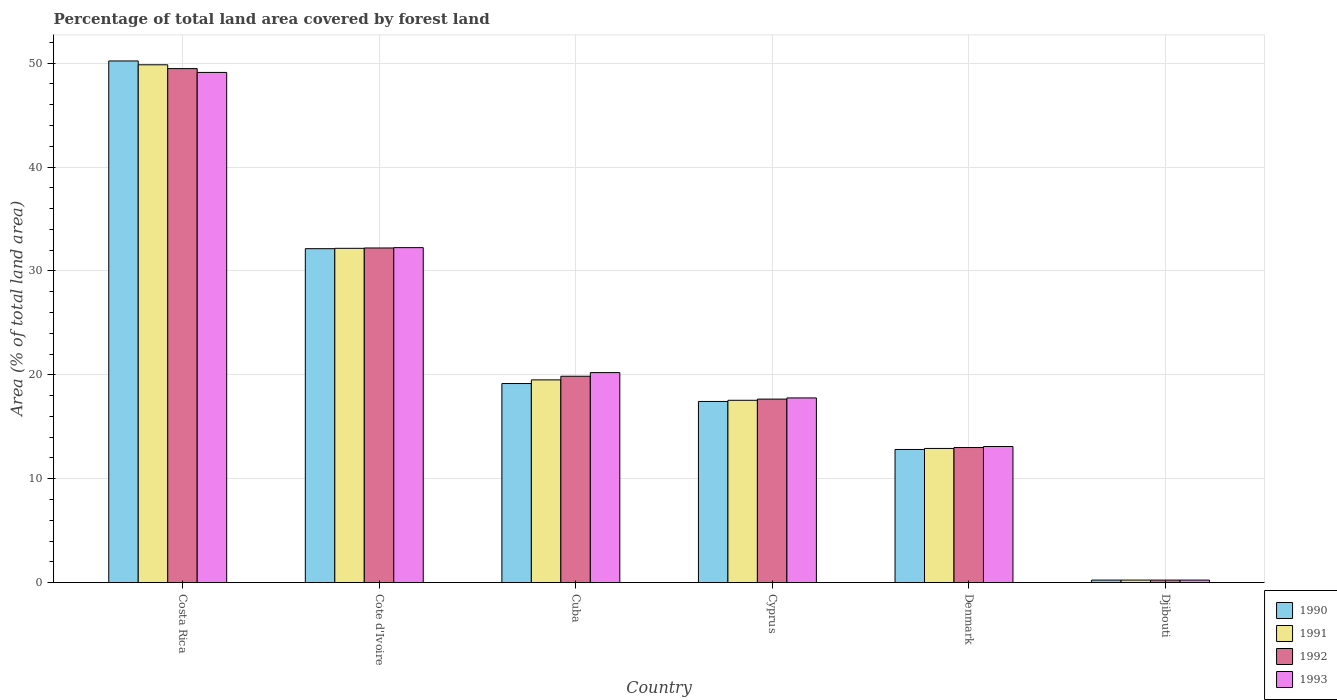How many different coloured bars are there?
Provide a short and direct response. 4. How many groups of bars are there?
Offer a very short reply. 6. Are the number of bars on each tick of the X-axis equal?
Offer a very short reply. Yes. How many bars are there on the 3rd tick from the left?
Keep it short and to the point. 4. What is the percentage of forest land in 1992 in Djibouti?
Provide a short and direct response. 0.24. Across all countries, what is the maximum percentage of forest land in 1993?
Provide a succinct answer. 49.11. Across all countries, what is the minimum percentage of forest land in 1990?
Provide a succinct answer. 0.24. In which country was the percentage of forest land in 1992 minimum?
Provide a succinct answer. Djibouti. What is the total percentage of forest land in 1992 in the graph?
Ensure brevity in your answer.  132.46. What is the difference between the percentage of forest land in 1990 in Cyprus and that in Denmark?
Your response must be concise. 4.62. What is the difference between the percentage of forest land in 1993 in Denmark and the percentage of forest land in 1990 in Cuba?
Offer a very short reply. -6.06. What is the average percentage of forest land in 1992 per country?
Give a very brief answer. 22.08. What is the difference between the percentage of forest land of/in 1992 and percentage of forest land of/in 1993 in Cuba?
Give a very brief answer. -0.35. In how many countries, is the percentage of forest land in 1993 greater than 38 %?
Make the answer very short. 1. What is the ratio of the percentage of forest land in 1993 in Cyprus to that in Djibouti?
Offer a very short reply. 73.58. Is the difference between the percentage of forest land in 1992 in Cuba and Djibouti greater than the difference between the percentage of forest land in 1993 in Cuba and Djibouti?
Provide a succinct answer. No. What is the difference between the highest and the second highest percentage of forest land in 1990?
Make the answer very short. -18.07. What is the difference between the highest and the lowest percentage of forest land in 1992?
Give a very brief answer. 49.24. Is the sum of the percentage of forest land in 1993 in Cyprus and Denmark greater than the maximum percentage of forest land in 1990 across all countries?
Make the answer very short. No. Is it the case that in every country, the sum of the percentage of forest land in 1992 and percentage of forest land in 1990 is greater than the sum of percentage of forest land in 1993 and percentage of forest land in 1991?
Keep it short and to the point. No. Are all the bars in the graph horizontal?
Ensure brevity in your answer.  No. What is the difference between two consecutive major ticks on the Y-axis?
Ensure brevity in your answer.  10. Are the values on the major ticks of Y-axis written in scientific E-notation?
Make the answer very short. No. Does the graph contain any zero values?
Offer a very short reply. No. What is the title of the graph?
Your answer should be very brief. Percentage of total land area covered by forest land. What is the label or title of the X-axis?
Ensure brevity in your answer.  Country. What is the label or title of the Y-axis?
Provide a short and direct response. Area (% of total land area). What is the Area (% of total land area) in 1990 in Costa Rica?
Offer a terse response. 50.22. What is the Area (% of total land area) in 1991 in Costa Rica?
Offer a very short reply. 49.85. What is the Area (% of total land area) of 1992 in Costa Rica?
Offer a terse response. 49.48. What is the Area (% of total land area) of 1993 in Costa Rica?
Give a very brief answer. 49.11. What is the Area (% of total land area) of 1990 in Cote d'Ivoire?
Your answer should be compact. 32.14. What is the Area (% of total land area) in 1991 in Cote d'Ivoire?
Your response must be concise. 32.18. What is the Area (% of total land area) in 1992 in Cote d'Ivoire?
Offer a very short reply. 32.21. What is the Area (% of total land area) of 1993 in Cote d'Ivoire?
Offer a very short reply. 32.24. What is the Area (% of total land area) in 1990 in Cuba?
Provide a succinct answer. 19.16. What is the Area (% of total land area) in 1991 in Cuba?
Offer a terse response. 19.51. What is the Area (% of total land area) in 1992 in Cuba?
Provide a short and direct response. 19.86. What is the Area (% of total land area) of 1993 in Cuba?
Provide a short and direct response. 20.22. What is the Area (% of total land area) of 1990 in Cyprus?
Your answer should be very brief. 17.44. What is the Area (% of total land area) of 1991 in Cyprus?
Offer a terse response. 17.55. What is the Area (% of total land area) of 1992 in Cyprus?
Provide a succinct answer. 17.66. What is the Area (% of total land area) of 1993 in Cyprus?
Keep it short and to the point. 17.78. What is the Area (% of total land area) in 1990 in Denmark?
Your answer should be very brief. 12.81. What is the Area (% of total land area) of 1991 in Denmark?
Ensure brevity in your answer.  12.91. What is the Area (% of total land area) in 1992 in Denmark?
Your answer should be compact. 13. What is the Area (% of total land area) of 1993 in Denmark?
Your response must be concise. 13.1. What is the Area (% of total land area) in 1990 in Djibouti?
Your response must be concise. 0.24. What is the Area (% of total land area) of 1991 in Djibouti?
Offer a terse response. 0.24. What is the Area (% of total land area) in 1992 in Djibouti?
Offer a very short reply. 0.24. What is the Area (% of total land area) in 1993 in Djibouti?
Make the answer very short. 0.24. Across all countries, what is the maximum Area (% of total land area) in 1990?
Ensure brevity in your answer.  50.22. Across all countries, what is the maximum Area (% of total land area) of 1991?
Offer a terse response. 49.85. Across all countries, what is the maximum Area (% of total land area) in 1992?
Keep it short and to the point. 49.48. Across all countries, what is the maximum Area (% of total land area) in 1993?
Give a very brief answer. 49.11. Across all countries, what is the minimum Area (% of total land area) of 1990?
Offer a very short reply. 0.24. Across all countries, what is the minimum Area (% of total land area) of 1991?
Keep it short and to the point. 0.24. Across all countries, what is the minimum Area (% of total land area) of 1992?
Keep it short and to the point. 0.24. Across all countries, what is the minimum Area (% of total land area) in 1993?
Give a very brief answer. 0.24. What is the total Area (% of total land area) of 1990 in the graph?
Give a very brief answer. 132.01. What is the total Area (% of total land area) of 1991 in the graph?
Ensure brevity in your answer.  132.24. What is the total Area (% of total land area) in 1992 in the graph?
Your answer should be very brief. 132.46. What is the total Area (% of total land area) of 1993 in the graph?
Keep it short and to the point. 132.69. What is the difference between the Area (% of total land area) in 1990 in Costa Rica and that in Cote d'Ivoire?
Keep it short and to the point. 18.07. What is the difference between the Area (% of total land area) of 1991 in Costa Rica and that in Cote d'Ivoire?
Your answer should be very brief. 17.67. What is the difference between the Area (% of total land area) in 1992 in Costa Rica and that in Cote d'Ivoire?
Provide a succinct answer. 17.27. What is the difference between the Area (% of total land area) of 1993 in Costa Rica and that in Cote d'Ivoire?
Give a very brief answer. 16.87. What is the difference between the Area (% of total land area) in 1990 in Costa Rica and that in Cuba?
Your response must be concise. 31.05. What is the difference between the Area (% of total land area) of 1991 in Costa Rica and that in Cuba?
Give a very brief answer. 30.33. What is the difference between the Area (% of total land area) in 1992 in Costa Rica and that in Cuba?
Your answer should be compact. 29.61. What is the difference between the Area (% of total land area) of 1993 in Costa Rica and that in Cuba?
Your answer should be compact. 28.9. What is the difference between the Area (% of total land area) of 1990 in Costa Rica and that in Cyprus?
Keep it short and to the point. 32.78. What is the difference between the Area (% of total land area) of 1991 in Costa Rica and that in Cyprus?
Your response must be concise. 32.3. What is the difference between the Area (% of total land area) in 1992 in Costa Rica and that in Cyprus?
Offer a terse response. 31.82. What is the difference between the Area (% of total land area) of 1993 in Costa Rica and that in Cyprus?
Make the answer very short. 31.33. What is the difference between the Area (% of total land area) in 1990 in Costa Rica and that in Denmark?
Keep it short and to the point. 37.4. What is the difference between the Area (% of total land area) of 1991 in Costa Rica and that in Denmark?
Provide a succinct answer. 36.93. What is the difference between the Area (% of total land area) of 1992 in Costa Rica and that in Denmark?
Ensure brevity in your answer.  36.48. What is the difference between the Area (% of total land area) in 1993 in Costa Rica and that in Denmark?
Your answer should be very brief. 36.01. What is the difference between the Area (% of total land area) of 1990 in Costa Rica and that in Djibouti?
Your response must be concise. 49.97. What is the difference between the Area (% of total land area) in 1991 in Costa Rica and that in Djibouti?
Keep it short and to the point. 49.61. What is the difference between the Area (% of total land area) of 1992 in Costa Rica and that in Djibouti?
Your answer should be very brief. 49.24. What is the difference between the Area (% of total land area) in 1993 in Costa Rica and that in Djibouti?
Offer a very short reply. 48.87. What is the difference between the Area (% of total land area) of 1990 in Cote d'Ivoire and that in Cuba?
Your response must be concise. 12.98. What is the difference between the Area (% of total land area) in 1991 in Cote d'Ivoire and that in Cuba?
Ensure brevity in your answer.  12.66. What is the difference between the Area (% of total land area) of 1992 in Cote d'Ivoire and that in Cuba?
Provide a short and direct response. 12.35. What is the difference between the Area (% of total land area) in 1993 in Cote d'Ivoire and that in Cuba?
Your answer should be compact. 12.03. What is the difference between the Area (% of total land area) in 1990 in Cote d'Ivoire and that in Cyprus?
Keep it short and to the point. 14.71. What is the difference between the Area (% of total land area) of 1991 in Cote d'Ivoire and that in Cyprus?
Offer a very short reply. 14.63. What is the difference between the Area (% of total land area) of 1992 in Cote d'Ivoire and that in Cyprus?
Your response must be concise. 14.55. What is the difference between the Area (% of total land area) of 1993 in Cote d'Ivoire and that in Cyprus?
Provide a short and direct response. 14.47. What is the difference between the Area (% of total land area) of 1990 in Cote d'Ivoire and that in Denmark?
Your response must be concise. 19.33. What is the difference between the Area (% of total land area) in 1991 in Cote d'Ivoire and that in Denmark?
Give a very brief answer. 19.26. What is the difference between the Area (% of total land area) in 1992 in Cote d'Ivoire and that in Denmark?
Your answer should be compact. 19.21. What is the difference between the Area (% of total land area) of 1993 in Cote d'Ivoire and that in Denmark?
Ensure brevity in your answer.  19.14. What is the difference between the Area (% of total land area) of 1990 in Cote d'Ivoire and that in Djibouti?
Offer a very short reply. 31.9. What is the difference between the Area (% of total land area) in 1991 in Cote d'Ivoire and that in Djibouti?
Make the answer very short. 31.94. What is the difference between the Area (% of total land area) in 1992 in Cote d'Ivoire and that in Djibouti?
Ensure brevity in your answer.  31.97. What is the difference between the Area (% of total land area) in 1993 in Cote d'Ivoire and that in Djibouti?
Provide a succinct answer. 32. What is the difference between the Area (% of total land area) in 1990 in Cuba and that in Cyprus?
Offer a very short reply. 1.73. What is the difference between the Area (% of total land area) in 1991 in Cuba and that in Cyprus?
Your response must be concise. 1.96. What is the difference between the Area (% of total land area) in 1992 in Cuba and that in Cyprus?
Your answer should be very brief. 2.2. What is the difference between the Area (% of total land area) of 1993 in Cuba and that in Cyprus?
Keep it short and to the point. 2.44. What is the difference between the Area (% of total land area) of 1990 in Cuba and that in Denmark?
Your answer should be compact. 6.35. What is the difference between the Area (% of total land area) in 1991 in Cuba and that in Denmark?
Make the answer very short. 6.6. What is the difference between the Area (% of total land area) in 1992 in Cuba and that in Denmark?
Offer a terse response. 6.86. What is the difference between the Area (% of total land area) in 1993 in Cuba and that in Denmark?
Your answer should be compact. 7.11. What is the difference between the Area (% of total land area) in 1990 in Cuba and that in Djibouti?
Your answer should be compact. 18.92. What is the difference between the Area (% of total land area) of 1991 in Cuba and that in Djibouti?
Keep it short and to the point. 19.27. What is the difference between the Area (% of total land area) in 1992 in Cuba and that in Djibouti?
Ensure brevity in your answer.  19.62. What is the difference between the Area (% of total land area) in 1993 in Cuba and that in Djibouti?
Make the answer very short. 19.97. What is the difference between the Area (% of total land area) in 1990 in Cyprus and that in Denmark?
Offer a very short reply. 4.62. What is the difference between the Area (% of total land area) in 1991 in Cyprus and that in Denmark?
Make the answer very short. 4.64. What is the difference between the Area (% of total land area) of 1992 in Cyprus and that in Denmark?
Make the answer very short. 4.66. What is the difference between the Area (% of total land area) in 1993 in Cyprus and that in Denmark?
Give a very brief answer. 4.68. What is the difference between the Area (% of total land area) in 1990 in Cyprus and that in Djibouti?
Provide a succinct answer. 17.19. What is the difference between the Area (% of total land area) in 1991 in Cyprus and that in Djibouti?
Your answer should be very brief. 17.31. What is the difference between the Area (% of total land area) in 1992 in Cyprus and that in Djibouti?
Make the answer very short. 17.42. What is the difference between the Area (% of total land area) in 1993 in Cyprus and that in Djibouti?
Offer a very short reply. 17.54. What is the difference between the Area (% of total land area) of 1990 in Denmark and that in Djibouti?
Give a very brief answer. 12.57. What is the difference between the Area (% of total land area) in 1991 in Denmark and that in Djibouti?
Make the answer very short. 12.67. What is the difference between the Area (% of total land area) in 1992 in Denmark and that in Djibouti?
Offer a very short reply. 12.76. What is the difference between the Area (% of total land area) of 1993 in Denmark and that in Djibouti?
Make the answer very short. 12.86. What is the difference between the Area (% of total land area) in 1990 in Costa Rica and the Area (% of total land area) in 1991 in Cote d'Ivoire?
Ensure brevity in your answer.  18.04. What is the difference between the Area (% of total land area) in 1990 in Costa Rica and the Area (% of total land area) in 1992 in Cote d'Ivoire?
Ensure brevity in your answer.  18. What is the difference between the Area (% of total land area) in 1990 in Costa Rica and the Area (% of total land area) in 1993 in Cote d'Ivoire?
Ensure brevity in your answer.  17.97. What is the difference between the Area (% of total land area) of 1991 in Costa Rica and the Area (% of total land area) of 1992 in Cote d'Ivoire?
Your answer should be compact. 17.64. What is the difference between the Area (% of total land area) in 1991 in Costa Rica and the Area (% of total land area) in 1993 in Cote d'Ivoire?
Offer a terse response. 17.6. What is the difference between the Area (% of total land area) of 1992 in Costa Rica and the Area (% of total land area) of 1993 in Cote d'Ivoire?
Provide a short and direct response. 17.23. What is the difference between the Area (% of total land area) in 1990 in Costa Rica and the Area (% of total land area) in 1991 in Cuba?
Provide a succinct answer. 30.7. What is the difference between the Area (% of total land area) in 1990 in Costa Rica and the Area (% of total land area) in 1992 in Cuba?
Your answer should be compact. 30.35. What is the difference between the Area (% of total land area) of 1990 in Costa Rica and the Area (% of total land area) of 1993 in Cuba?
Your response must be concise. 30. What is the difference between the Area (% of total land area) in 1991 in Costa Rica and the Area (% of total land area) in 1992 in Cuba?
Your answer should be very brief. 29.98. What is the difference between the Area (% of total land area) in 1991 in Costa Rica and the Area (% of total land area) in 1993 in Cuba?
Keep it short and to the point. 29.63. What is the difference between the Area (% of total land area) of 1992 in Costa Rica and the Area (% of total land area) of 1993 in Cuba?
Offer a terse response. 29.26. What is the difference between the Area (% of total land area) of 1990 in Costa Rica and the Area (% of total land area) of 1991 in Cyprus?
Provide a short and direct response. 32.67. What is the difference between the Area (% of total land area) in 1990 in Costa Rica and the Area (% of total land area) in 1992 in Cyprus?
Give a very brief answer. 32.55. What is the difference between the Area (% of total land area) of 1990 in Costa Rica and the Area (% of total land area) of 1993 in Cyprus?
Your response must be concise. 32.44. What is the difference between the Area (% of total land area) in 1991 in Costa Rica and the Area (% of total land area) in 1992 in Cyprus?
Ensure brevity in your answer.  32.18. What is the difference between the Area (% of total land area) of 1991 in Costa Rica and the Area (% of total land area) of 1993 in Cyprus?
Provide a short and direct response. 32.07. What is the difference between the Area (% of total land area) of 1992 in Costa Rica and the Area (% of total land area) of 1993 in Cyprus?
Your response must be concise. 31.7. What is the difference between the Area (% of total land area) of 1990 in Costa Rica and the Area (% of total land area) of 1991 in Denmark?
Your answer should be very brief. 37.3. What is the difference between the Area (% of total land area) in 1990 in Costa Rica and the Area (% of total land area) in 1992 in Denmark?
Make the answer very short. 37.21. What is the difference between the Area (% of total land area) of 1990 in Costa Rica and the Area (% of total land area) of 1993 in Denmark?
Your answer should be very brief. 37.11. What is the difference between the Area (% of total land area) in 1991 in Costa Rica and the Area (% of total land area) in 1992 in Denmark?
Make the answer very short. 36.85. What is the difference between the Area (% of total land area) of 1991 in Costa Rica and the Area (% of total land area) of 1993 in Denmark?
Keep it short and to the point. 36.75. What is the difference between the Area (% of total land area) of 1992 in Costa Rica and the Area (% of total land area) of 1993 in Denmark?
Give a very brief answer. 36.38. What is the difference between the Area (% of total land area) in 1990 in Costa Rica and the Area (% of total land area) in 1991 in Djibouti?
Offer a terse response. 49.97. What is the difference between the Area (% of total land area) in 1990 in Costa Rica and the Area (% of total land area) in 1992 in Djibouti?
Your answer should be very brief. 49.97. What is the difference between the Area (% of total land area) in 1990 in Costa Rica and the Area (% of total land area) in 1993 in Djibouti?
Provide a short and direct response. 49.97. What is the difference between the Area (% of total land area) in 1991 in Costa Rica and the Area (% of total land area) in 1992 in Djibouti?
Make the answer very short. 49.61. What is the difference between the Area (% of total land area) of 1991 in Costa Rica and the Area (% of total land area) of 1993 in Djibouti?
Offer a terse response. 49.61. What is the difference between the Area (% of total land area) in 1992 in Costa Rica and the Area (% of total land area) in 1993 in Djibouti?
Make the answer very short. 49.24. What is the difference between the Area (% of total land area) of 1990 in Cote d'Ivoire and the Area (% of total land area) of 1991 in Cuba?
Ensure brevity in your answer.  12.63. What is the difference between the Area (% of total land area) in 1990 in Cote d'Ivoire and the Area (% of total land area) in 1992 in Cuba?
Offer a terse response. 12.28. What is the difference between the Area (% of total land area) in 1990 in Cote d'Ivoire and the Area (% of total land area) in 1993 in Cuba?
Ensure brevity in your answer.  11.93. What is the difference between the Area (% of total land area) in 1991 in Cote d'Ivoire and the Area (% of total land area) in 1992 in Cuba?
Your answer should be very brief. 12.31. What is the difference between the Area (% of total land area) of 1991 in Cote d'Ivoire and the Area (% of total land area) of 1993 in Cuba?
Make the answer very short. 11.96. What is the difference between the Area (% of total land area) in 1992 in Cote d'Ivoire and the Area (% of total land area) in 1993 in Cuba?
Give a very brief answer. 12. What is the difference between the Area (% of total land area) of 1990 in Cote d'Ivoire and the Area (% of total land area) of 1991 in Cyprus?
Make the answer very short. 14.59. What is the difference between the Area (% of total land area) in 1990 in Cote d'Ivoire and the Area (% of total land area) in 1992 in Cyprus?
Provide a short and direct response. 14.48. What is the difference between the Area (% of total land area) of 1990 in Cote d'Ivoire and the Area (% of total land area) of 1993 in Cyprus?
Give a very brief answer. 14.37. What is the difference between the Area (% of total land area) of 1991 in Cote d'Ivoire and the Area (% of total land area) of 1992 in Cyprus?
Provide a short and direct response. 14.51. What is the difference between the Area (% of total land area) in 1991 in Cote d'Ivoire and the Area (% of total land area) in 1993 in Cyprus?
Make the answer very short. 14.4. What is the difference between the Area (% of total land area) of 1992 in Cote d'Ivoire and the Area (% of total land area) of 1993 in Cyprus?
Your response must be concise. 14.43. What is the difference between the Area (% of total land area) in 1990 in Cote d'Ivoire and the Area (% of total land area) in 1991 in Denmark?
Your answer should be very brief. 19.23. What is the difference between the Area (% of total land area) of 1990 in Cote d'Ivoire and the Area (% of total land area) of 1992 in Denmark?
Offer a very short reply. 19.14. What is the difference between the Area (% of total land area) of 1990 in Cote d'Ivoire and the Area (% of total land area) of 1993 in Denmark?
Offer a terse response. 19.04. What is the difference between the Area (% of total land area) of 1991 in Cote d'Ivoire and the Area (% of total land area) of 1992 in Denmark?
Offer a very short reply. 19.18. What is the difference between the Area (% of total land area) of 1991 in Cote d'Ivoire and the Area (% of total land area) of 1993 in Denmark?
Keep it short and to the point. 19.08. What is the difference between the Area (% of total land area) of 1992 in Cote d'Ivoire and the Area (% of total land area) of 1993 in Denmark?
Give a very brief answer. 19.11. What is the difference between the Area (% of total land area) in 1990 in Cote d'Ivoire and the Area (% of total land area) in 1991 in Djibouti?
Offer a very short reply. 31.9. What is the difference between the Area (% of total land area) in 1990 in Cote d'Ivoire and the Area (% of total land area) in 1992 in Djibouti?
Give a very brief answer. 31.9. What is the difference between the Area (% of total land area) of 1990 in Cote d'Ivoire and the Area (% of total land area) of 1993 in Djibouti?
Your response must be concise. 31.9. What is the difference between the Area (% of total land area) of 1991 in Cote d'Ivoire and the Area (% of total land area) of 1992 in Djibouti?
Make the answer very short. 31.94. What is the difference between the Area (% of total land area) in 1991 in Cote d'Ivoire and the Area (% of total land area) in 1993 in Djibouti?
Offer a very short reply. 31.94. What is the difference between the Area (% of total land area) in 1992 in Cote d'Ivoire and the Area (% of total land area) in 1993 in Djibouti?
Your answer should be very brief. 31.97. What is the difference between the Area (% of total land area) of 1990 in Cuba and the Area (% of total land area) of 1991 in Cyprus?
Your response must be concise. 1.61. What is the difference between the Area (% of total land area) in 1990 in Cuba and the Area (% of total land area) in 1992 in Cyprus?
Your response must be concise. 1.5. What is the difference between the Area (% of total land area) of 1990 in Cuba and the Area (% of total land area) of 1993 in Cyprus?
Your answer should be very brief. 1.39. What is the difference between the Area (% of total land area) in 1991 in Cuba and the Area (% of total land area) in 1992 in Cyprus?
Offer a very short reply. 1.85. What is the difference between the Area (% of total land area) of 1991 in Cuba and the Area (% of total land area) of 1993 in Cyprus?
Make the answer very short. 1.74. What is the difference between the Area (% of total land area) in 1992 in Cuba and the Area (% of total land area) in 1993 in Cyprus?
Your response must be concise. 2.09. What is the difference between the Area (% of total land area) of 1990 in Cuba and the Area (% of total land area) of 1991 in Denmark?
Make the answer very short. 6.25. What is the difference between the Area (% of total land area) in 1990 in Cuba and the Area (% of total land area) in 1992 in Denmark?
Offer a terse response. 6.16. What is the difference between the Area (% of total land area) in 1990 in Cuba and the Area (% of total land area) in 1993 in Denmark?
Keep it short and to the point. 6.06. What is the difference between the Area (% of total land area) in 1991 in Cuba and the Area (% of total land area) in 1992 in Denmark?
Provide a short and direct response. 6.51. What is the difference between the Area (% of total land area) of 1991 in Cuba and the Area (% of total land area) of 1993 in Denmark?
Offer a very short reply. 6.41. What is the difference between the Area (% of total land area) in 1992 in Cuba and the Area (% of total land area) in 1993 in Denmark?
Keep it short and to the point. 6.76. What is the difference between the Area (% of total land area) of 1990 in Cuba and the Area (% of total land area) of 1991 in Djibouti?
Your answer should be very brief. 18.92. What is the difference between the Area (% of total land area) of 1990 in Cuba and the Area (% of total land area) of 1992 in Djibouti?
Provide a short and direct response. 18.92. What is the difference between the Area (% of total land area) in 1990 in Cuba and the Area (% of total land area) in 1993 in Djibouti?
Your response must be concise. 18.92. What is the difference between the Area (% of total land area) in 1991 in Cuba and the Area (% of total land area) in 1992 in Djibouti?
Your answer should be very brief. 19.27. What is the difference between the Area (% of total land area) in 1991 in Cuba and the Area (% of total land area) in 1993 in Djibouti?
Your answer should be very brief. 19.27. What is the difference between the Area (% of total land area) in 1992 in Cuba and the Area (% of total land area) in 1993 in Djibouti?
Offer a very short reply. 19.62. What is the difference between the Area (% of total land area) in 1990 in Cyprus and the Area (% of total land area) in 1991 in Denmark?
Your answer should be very brief. 4.52. What is the difference between the Area (% of total land area) of 1990 in Cyprus and the Area (% of total land area) of 1992 in Denmark?
Ensure brevity in your answer.  4.43. What is the difference between the Area (% of total land area) in 1990 in Cyprus and the Area (% of total land area) in 1993 in Denmark?
Your response must be concise. 4.33. What is the difference between the Area (% of total land area) of 1991 in Cyprus and the Area (% of total land area) of 1992 in Denmark?
Offer a very short reply. 4.55. What is the difference between the Area (% of total land area) of 1991 in Cyprus and the Area (% of total land area) of 1993 in Denmark?
Offer a terse response. 4.45. What is the difference between the Area (% of total land area) of 1992 in Cyprus and the Area (% of total land area) of 1993 in Denmark?
Your response must be concise. 4.56. What is the difference between the Area (% of total land area) of 1990 in Cyprus and the Area (% of total land area) of 1991 in Djibouti?
Make the answer very short. 17.19. What is the difference between the Area (% of total land area) of 1990 in Cyprus and the Area (% of total land area) of 1992 in Djibouti?
Provide a short and direct response. 17.19. What is the difference between the Area (% of total land area) in 1990 in Cyprus and the Area (% of total land area) in 1993 in Djibouti?
Offer a terse response. 17.19. What is the difference between the Area (% of total land area) of 1991 in Cyprus and the Area (% of total land area) of 1992 in Djibouti?
Your response must be concise. 17.31. What is the difference between the Area (% of total land area) of 1991 in Cyprus and the Area (% of total land area) of 1993 in Djibouti?
Ensure brevity in your answer.  17.31. What is the difference between the Area (% of total land area) of 1992 in Cyprus and the Area (% of total land area) of 1993 in Djibouti?
Give a very brief answer. 17.42. What is the difference between the Area (% of total land area) of 1990 in Denmark and the Area (% of total land area) of 1991 in Djibouti?
Keep it short and to the point. 12.57. What is the difference between the Area (% of total land area) of 1990 in Denmark and the Area (% of total land area) of 1992 in Djibouti?
Make the answer very short. 12.57. What is the difference between the Area (% of total land area) in 1990 in Denmark and the Area (% of total land area) in 1993 in Djibouti?
Your answer should be compact. 12.57. What is the difference between the Area (% of total land area) of 1991 in Denmark and the Area (% of total land area) of 1992 in Djibouti?
Your answer should be very brief. 12.67. What is the difference between the Area (% of total land area) of 1991 in Denmark and the Area (% of total land area) of 1993 in Djibouti?
Give a very brief answer. 12.67. What is the difference between the Area (% of total land area) in 1992 in Denmark and the Area (% of total land area) in 1993 in Djibouti?
Give a very brief answer. 12.76. What is the average Area (% of total land area) in 1990 per country?
Give a very brief answer. 22. What is the average Area (% of total land area) of 1991 per country?
Your answer should be compact. 22.04. What is the average Area (% of total land area) in 1992 per country?
Ensure brevity in your answer.  22.08. What is the average Area (% of total land area) of 1993 per country?
Make the answer very short. 22.12. What is the difference between the Area (% of total land area) in 1990 and Area (% of total land area) in 1991 in Costa Rica?
Provide a succinct answer. 0.37. What is the difference between the Area (% of total land area) of 1990 and Area (% of total land area) of 1992 in Costa Rica?
Offer a terse response. 0.74. What is the difference between the Area (% of total land area) in 1990 and Area (% of total land area) in 1993 in Costa Rica?
Your answer should be very brief. 1.1. What is the difference between the Area (% of total land area) in 1991 and Area (% of total land area) in 1992 in Costa Rica?
Offer a very short reply. 0.37. What is the difference between the Area (% of total land area) in 1991 and Area (% of total land area) in 1993 in Costa Rica?
Keep it short and to the point. 0.74. What is the difference between the Area (% of total land area) in 1992 and Area (% of total land area) in 1993 in Costa Rica?
Your response must be concise. 0.37. What is the difference between the Area (% of total land area) in 1990 and Area (% of total land area) in 1991 in Cote d'Ivoire?
Your response must be concise. -0.03. What is the difference between the Area (% of total land area) in 1990 and Area (% of total land area) in 1992 in Cote d'Ivoire?
Your response must be concise. -0.07. What is the difference between the Area (% of total land area) of 1990 and Area (% of total land area) of 1993 in Cote d'Ivoire?
Provide a short and direct response. -0.1. What is the difference between the Area (% of total land area) of 1991 and Area (% of total land area) of 1992 in Cote d'Ivoire?
Keep it short and to the point. -0.03. What is the difference between the Area (% of total land area) in 1991 and Area (% of total land area) in 1993 in Cote d'Ivoire?
Keep it short and to the point. -0.07. What is the difference between the Area (% of total land area) in 1992 and Area (% of total land area) in 1993 in Cote d'Ivoire?
Offer a terse response. -0.03. What is the difference between the Area (% of total land area) in 1990 and Area (% of total land area) in 1991 in Cuba?
Offer a terse response. -0.35. What is the difference between the Area (% of total land area) in 1990 and Area (% of total land area) in 1992 in Cuba?
Make the answer very short. -0.7. What is the difference between the Area (% of total land area) of 1990 and Area (% of total land area) of 1993 in Cuba?
Offer a very short reply. -1.05. What is the difference between the Area (% of total land area) in 1991 and Area (% of total land area) in 1992 in Cuba?
Your answer should be compact. -0.35. What is the difference between the Area (% of total land area) of 1991 and Area (% of total land area) of 1993 in Cuba?
Your answer should be compact. -0.7. What is the difference between the Area (% of total land area) of 1992 and Area (% of total land area) of 1993 in Cuba?
Keep it short and to the point. -0.35. What is the difference between the Area (% of total land area) in 1990 and Area (% of total land area) in 1991 in Cyprus?
Your response must be concise. -0.11. What is the difference between the Area (% of total land area) in 1990 and Area (% of total land area) in 1992 in Cyprus?
Ensure brevity in your answer.  -0.23. What is the difference between the Area (% of total land area) of 1990 and Area (% of total land area) of 1993 in Cyprus?
Your response must be concise. -0.34. What is the difference between the Area (% of total land area) of 1991 and Area (% of total land area) of 1992 in Cyprus?
Your response must be concise. -0.11. What is the difference between the Area (% of total land area) of 1991 and Area (% of total land area) of 1993 in Cyprus?
Your response must be concise. -0.23. What is the difference between the Area (% of total land area) of 1992 and Area (% of total land area) of 1993 in Cyprus?
Provide a short and direct response. -0.11. What is the difference between the Area (% of total land area) in 1990 and Area (% of total land area) in 1991 in Denmark?
Make the answer very short. -0.1. What is the difference between the Area (% of total land area) in 1990 and Area (% of total land area) in 1992 in Denmark?
Your response must be concise. -0.19. What is the difference between the Area (% of total land area) in 1990 and Area (% of total land area) in 1993 in Denmark?
Give a very brief answer. -0.29. What is the difference between the Area (% of total land area) in 1991 and Area (% of total land area) in 1992 in Denmark?
Offer a very short reply. -0.09. What is the difference between the Area (% of total land area) of 1991 and Area (% of total land area) of 1993 in Denmark?
Offer a very short reply. -0.19. What is the difference between the Area (% of total land area) in 1992 and Area (% of total land area) in 1993 in Denmark?
Give a very brief answer. -0.1. What is the difference between the Area (% of total land area) of 1990 and Area (% of total land area) of 1991 in Djibouti?
Offer a terse response. 0. What is the difference between the Area (% of total land area) of 1991 and Area (% of total land area) of 1992 in Djibouti?
Ensure brevity in your answer.  0. What is the ratio of the Area (% of total land area) of 1990 in Costa Rica to that in Cote d'Ivoire?
Provide a short and direct response. 1.56. What is the ratio of the Area (% of total land area) in 1991 in Costa Rica to that in Cote d'Ivoire?
Give a very brief answer. 1.55. What is the ratio of the Area (% of total land area) of 1992 in Costa Rica to that in Cote d'Ivoire?
Provide a succinct answer. 1.54. What is the ratio of the Area (% of total land area) in 1993 in Costa Rica to that in Cote d'Ivoire?
Make the answer very short. 1.52. What is the ratio of the Area (% of total land area) in 1990 in Costa Rica to that in Cuba?
Make the answer very short. 2.62. What is the ratio of the Area (% of total land area) in 1991 in Costa Rica to that in Cuba?
Give a very brief answer. 2.55. What is the ratio of the Area (% of total land area) in 1992 in Costa Rica to that in Cuba?
Provide a succinct answer. 2.49. What is the ratio of the Area (% of total land area) of 1993 in Costa Rica to that in Cuba?
Keep it short and to the point. 2.43. What is the ratio of the Area (% of total land area) of 1990 in Costa Rica to that in Cyprus?
Ensure brevity in your answer.  2.88. What is the ratio of the Area (% of total land area) in 1991 in Costa Rica to that in Cyprus?
Your answer should be very brief. 2.84. What is the ratio of the Area (% of total land area) in 1992 in Costa Rica to that in Cyprus?
Keep it short and to the point. 2.8. What is the ratio of the Area (% of total land area) in 1993 in Costa Rica to that in Cyprus?
Provide a succinct answer. 2.76. What is the ratio of the Area (% of total land area) of 1990 in Costa Rica to that in Denmark?
Keep it short and to the point. 3.92. What is the ratio of the Area (% of total land area) of 1991 in Costa Rica to that in Denmark?
Provide a short and direct response. 3.86. What is the ratio of the Area (% of total land area) of 1992 in Costa Rica to that in Denmark?
Your answer should be compact. 3.81. What is the ratio of the Area (% of total land area) of 1993 in Costa Rica to that in Denmark?
Your answer should be very brief. 3.75. What is the ratio of the Area (% of total land area) of 1990 in Costa Rica to that in Djibouti?
Give a very brief answer. 207.86. What is the ratio of the Area (% of total land area) in 1991 in Costa Rica to that in Djibouti?
Your answer should be very brief. 206.33. What is the ratio of the Area (% of total land area) in 1992 in Costa Rica to that in Djibouti?
Your answer should be very brief. 204.81. What is the ratio of the Area (% of total land area) of 1993 in Costa Rica to that in Djibouti?
Your response must be concise. 203.28. What is the ratio of the Area (% of total land area) in 1990 in Cote d'Ivoire to that in Cuba?
Ensure brevity in your answer.  1.68. What is the ratio of the Area (% of total land area) of 1991 in Cote d'Ivoire to that in Cuba?
Offer a terse response. 1.65. What is the ratio of the Area (% of total land area) of 1992 in Cote d'Ivoire to that in Cuba?
Make the answer very short. 1.62. What is the ratio of the Area (% of total land area) in 1993 in Cote d'Ivoire to that in Cuba?
Give a very brief answer. 1.6. What is the ratio of the Area (% of total land area) in 1990 in Cote d'Ivoire to that in Cyprus?
Make the answer very short. 1.84. What is the ratio of the Area (% of total land area) in 1991 in Cote d'Ivoire to that in Cyprus?
Keep it short and to the point. 1.83. What is the ratio of the Area (% of total land area) in 1992 in Cote d'Ivoire to that in Cyprus?
Make the answer very short. 1.82. What is the ratio of the Area (% of total land area) of 1993 in Cote d'Ivoire to that in Cyprus?
Provide a succinct answer. 1.81. What is the ratio of the Area (% of total land area) in 1990 in Cote d'Ivoire to that in Denmark?
Your answer should be very brief. 2.51. What is the ratio of the Area (% of total land area) in 1991 in Cote d'Ivoire to that in Denmark?
Give a very brief answer. 2.49. What is the ratio of the Area (% of total land area) in 1992 in Cote d'Ivoire to that in Denmark?
Ensure brevity in your answer.  2.48. What is the ratio of the Area (% of total land area) of 1993 in Cote d'Ivoire to that in Denmark?
Offer a very short reply. 2.46. What is the ratio of the Area (% of total land area) of 1990 in Cote d'Ivoire to that in Djibouti?
Offer a terse response. 133.06. What is the ratio of the Area (% of total land area) of 1991 in Cote d'Ivoire to that in Djibouti?
Give a very brief answer. 133.19. What is the ratio of the Area (% of total land area) in 1992 in Cote d'Ivoire to that in Djibouti?
Your answer should be compact. 133.33. What is the ratio of the Area (% of total land area) in 1993 in Cote d'Ivoire to that in Djibouti?
Your answer should be very brief. 133.47. What is the ratio of the Area (% of total land area) in 1990 in Cuba to that in Cyprus?
Your answer should be compact. 1.1. What is the ratio of the Area (% of total land area) in 1991 in Cuba to that in Cyprus?
Make the answer very short. 1.11. What is the ratio of the Area (% of total land area) in 1992 in Cuba to that in Cyprus?
Keep it short and to the point. 1.12. What is the ratio of the Area (% of total land area) of 1993 in Cuba to that in Cyprus?
Offer a very short reply. 1.14. What is the ratio of the Area (% of total land area) in 1990 in Cuba to that in Denmark?
Your answer should be very brief. 1.5. What is the ratio of the Area (% of total land area) in 1991 in Cuba to that in Denmark?
Offer a very short reply. 1.51. What is the ratio of the Area (% of total land area) of 1992 in Cuba to that in Denmark?
Make the answer very short. 1.53. What is the ratio of the Area (% of total land area) of 1993 in Cuba to that in Denmark?
Give a very brief answer. 1.54. What is the ratio of the Area (% of total land area) in 1990 in Cuba to that in Djibouti?
Provide a succinct answer. 79.32. What is the ratio of the Area (% of total land area) in 1991 in Cuba to that in Djibouti?
Offer a very short reply. 80.77. What is the ratio of the Area (% of total land area) in 1992 in Cuba to that in Djibouti?
Offer a very short reply. 82.22. What is the ratio of the Area (% of total land area) in 1993 in Cuba to that in Djibouti?
Make the answer very short. 83.68. What is the ratio of the Area (% of total land area) in 1990 in Cyprus to that in Denmark?
Your answer should be very brief. 1.36. What is the ratio of the Area (% of total land area) in 1991 in Cyprus to that in Denmark?
Ensure brevity in your answer.  1.36. What is the ratio of the Area (% of total land area) of 1992 in Cyprus to that in Denmark?
Ensure brevity in your answer.  1.36. What is the ratio of the Area (% of total land area) in 1993 in Cyprus to that in Denmark?
Offer a terse response. 1.36. What is the ratio of the Area (% of total land area) of 1990 in Cyprus to that in Djibouti?
Your answer should be very brief. 72.17. What is the ratio of the Area (% of total land area) of 1991 in Cyprus to that in Djibouti?
Ensure brevity in your answer.  72.64. What is the ratio of the Area (% of total land area) in 1992 in Cyprus to that in Djibouti?
Your answer should be compact. 73.11. What is the ratio of the Area (% of total land area) of 1993 in Cyprus to that in Djibouti?
Make the answer very short. 73.58. What is the ratio of the Area (% of total land area) in 1990 in Denmark to that in Djibouti?
Your answer should be compact. 53.04. What is the ratio of the Area (% of total land area) of 1991 in Denmark to that in Djibouti?
Your answer should be compact. 53.46. What is the ratio of the Area (% of total land area) in 1992 in Denmark to that in Djibouti?
Give a very brief answer. 53.82. What is the ratio of the Area (% of total land area) of 1993 in Denmark to that in Djibouti?
Offer a very short reply. 54.23. What is the difference between the highest and the second highest Area (% of total land area) in 1990?
Your answer should be very brief. 18.07. What is the difference between the highest and the second highest Area (% of total land area) of 1991?
Give a very brief answer. 17.67. What is the difference between the highest and the second highest Area (% of total land area) of 1992?
Offer a very short reply. 17.27. What is the difference between the highest and the second highest Area (% of total land area) in 1993?
Offer a very short reply. 16.87. What is the difference between the highest and the lowest Area (% of total land area) of 1990?
Offer a terse response. 49.97. What is the difference between the highest and the lowest Area (% of total land area) of 1991?
Offer a terse response. 49.61. What is the difference between the highest and the lowest Area (% of total land area) in 1992?
Your response must be concise. 49.24. What is the difference between the highest and the lowest Area (% of total land area) in 1993?
Your answer should be compact. 48.87. 